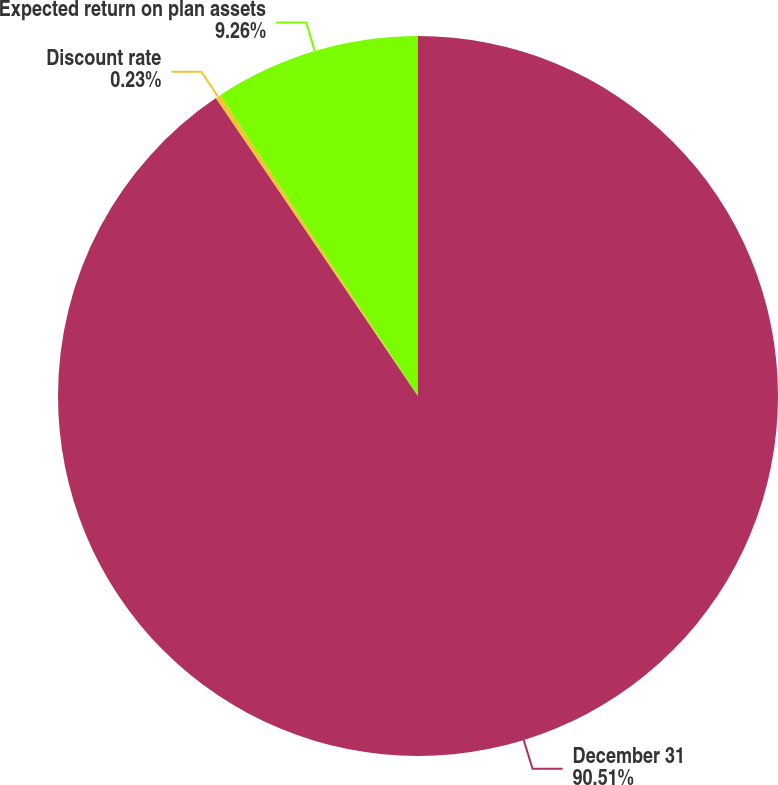<chart> <loc_0><loc_0><loc_500><loc_500><pie_chart><fcel>December 31<fcel>Discount rate<fcel>Expected return on plan assets<nl><fcel>90.52%<fcel>0.23%<fcel>9.26%<nl></chart> 